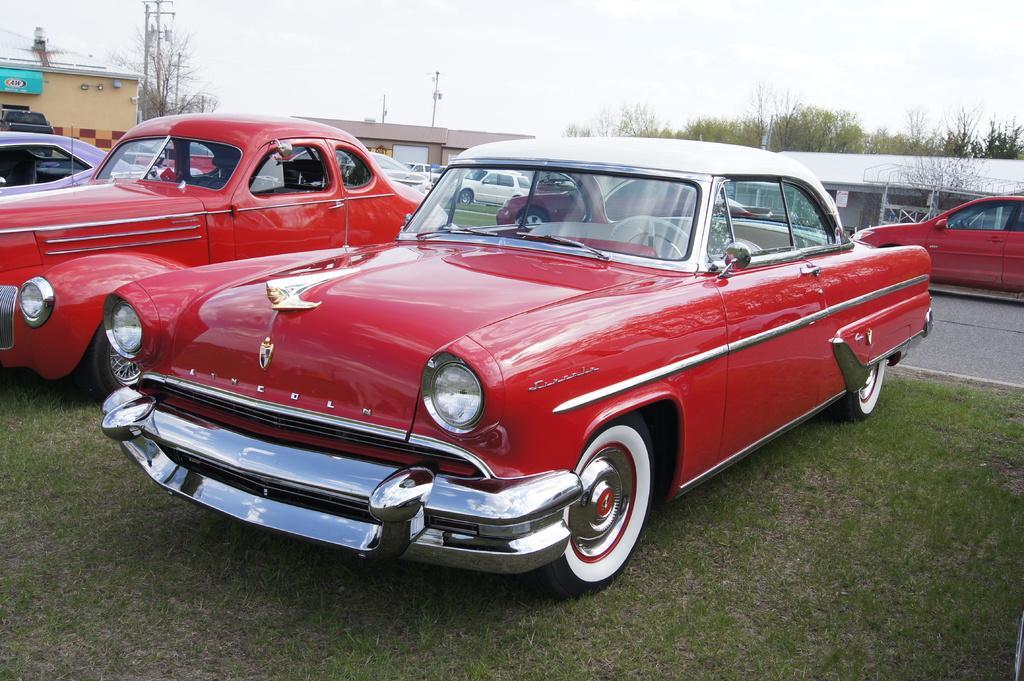In one or two sentences, can you explain what this image depicts? In the picture we can see some vintage cars are parked on the grass surface, cars are red in color and behind the cars we can see a road on it, we can see a car which is red in color and in the background we can see some dried trees, poles and houses and behind it we can see the sky. 